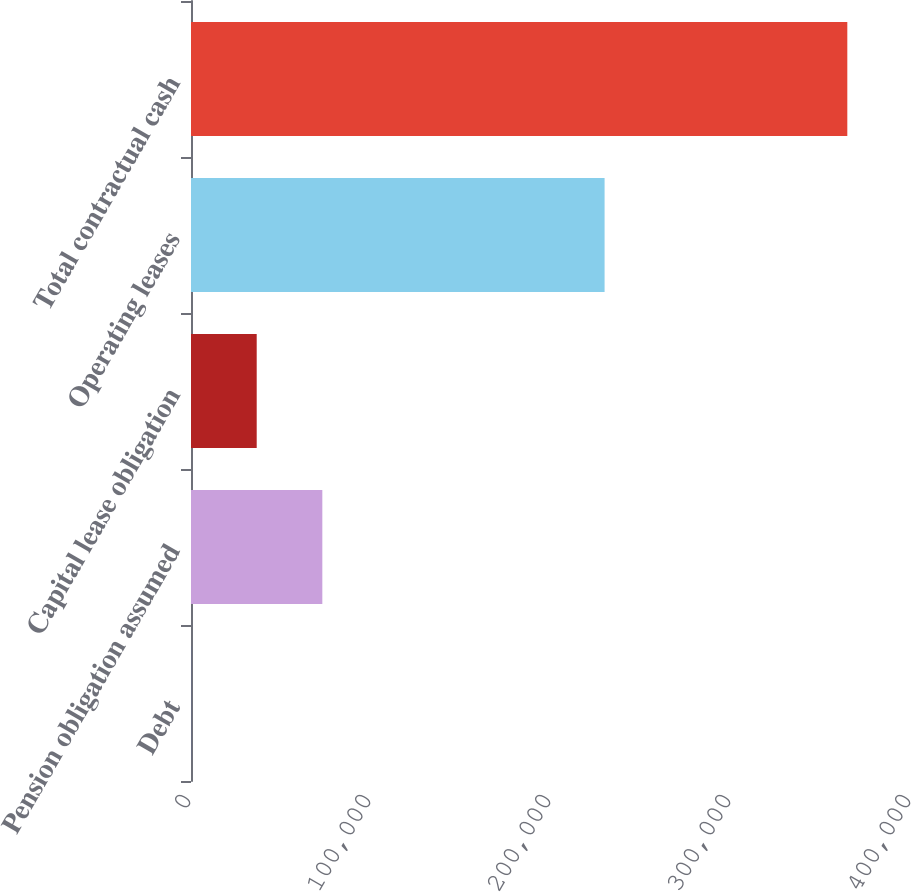<chart> <loc_0><loc_0><loc_500><loc_500><bar_chart><fcel>Debt<fcel>Pension obligation assumed<fcel>Capital lease obligation<fcel>Operating leases<fcel>Total contractual cash<nl><fcel>45<fcel>72959.6<fcel>36502.3<fcel>229768<fcel>364618<nl></chart> 